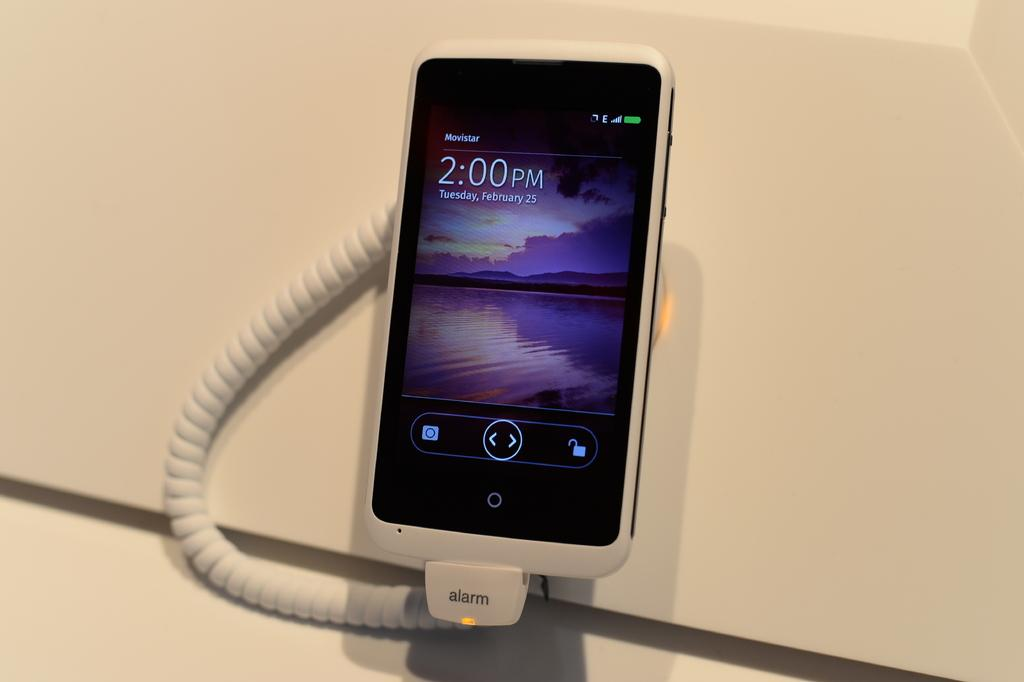Provide a one-sentence caption for the provided image. A movistar phone hooked up to an old telephone style cord that says alarm. 